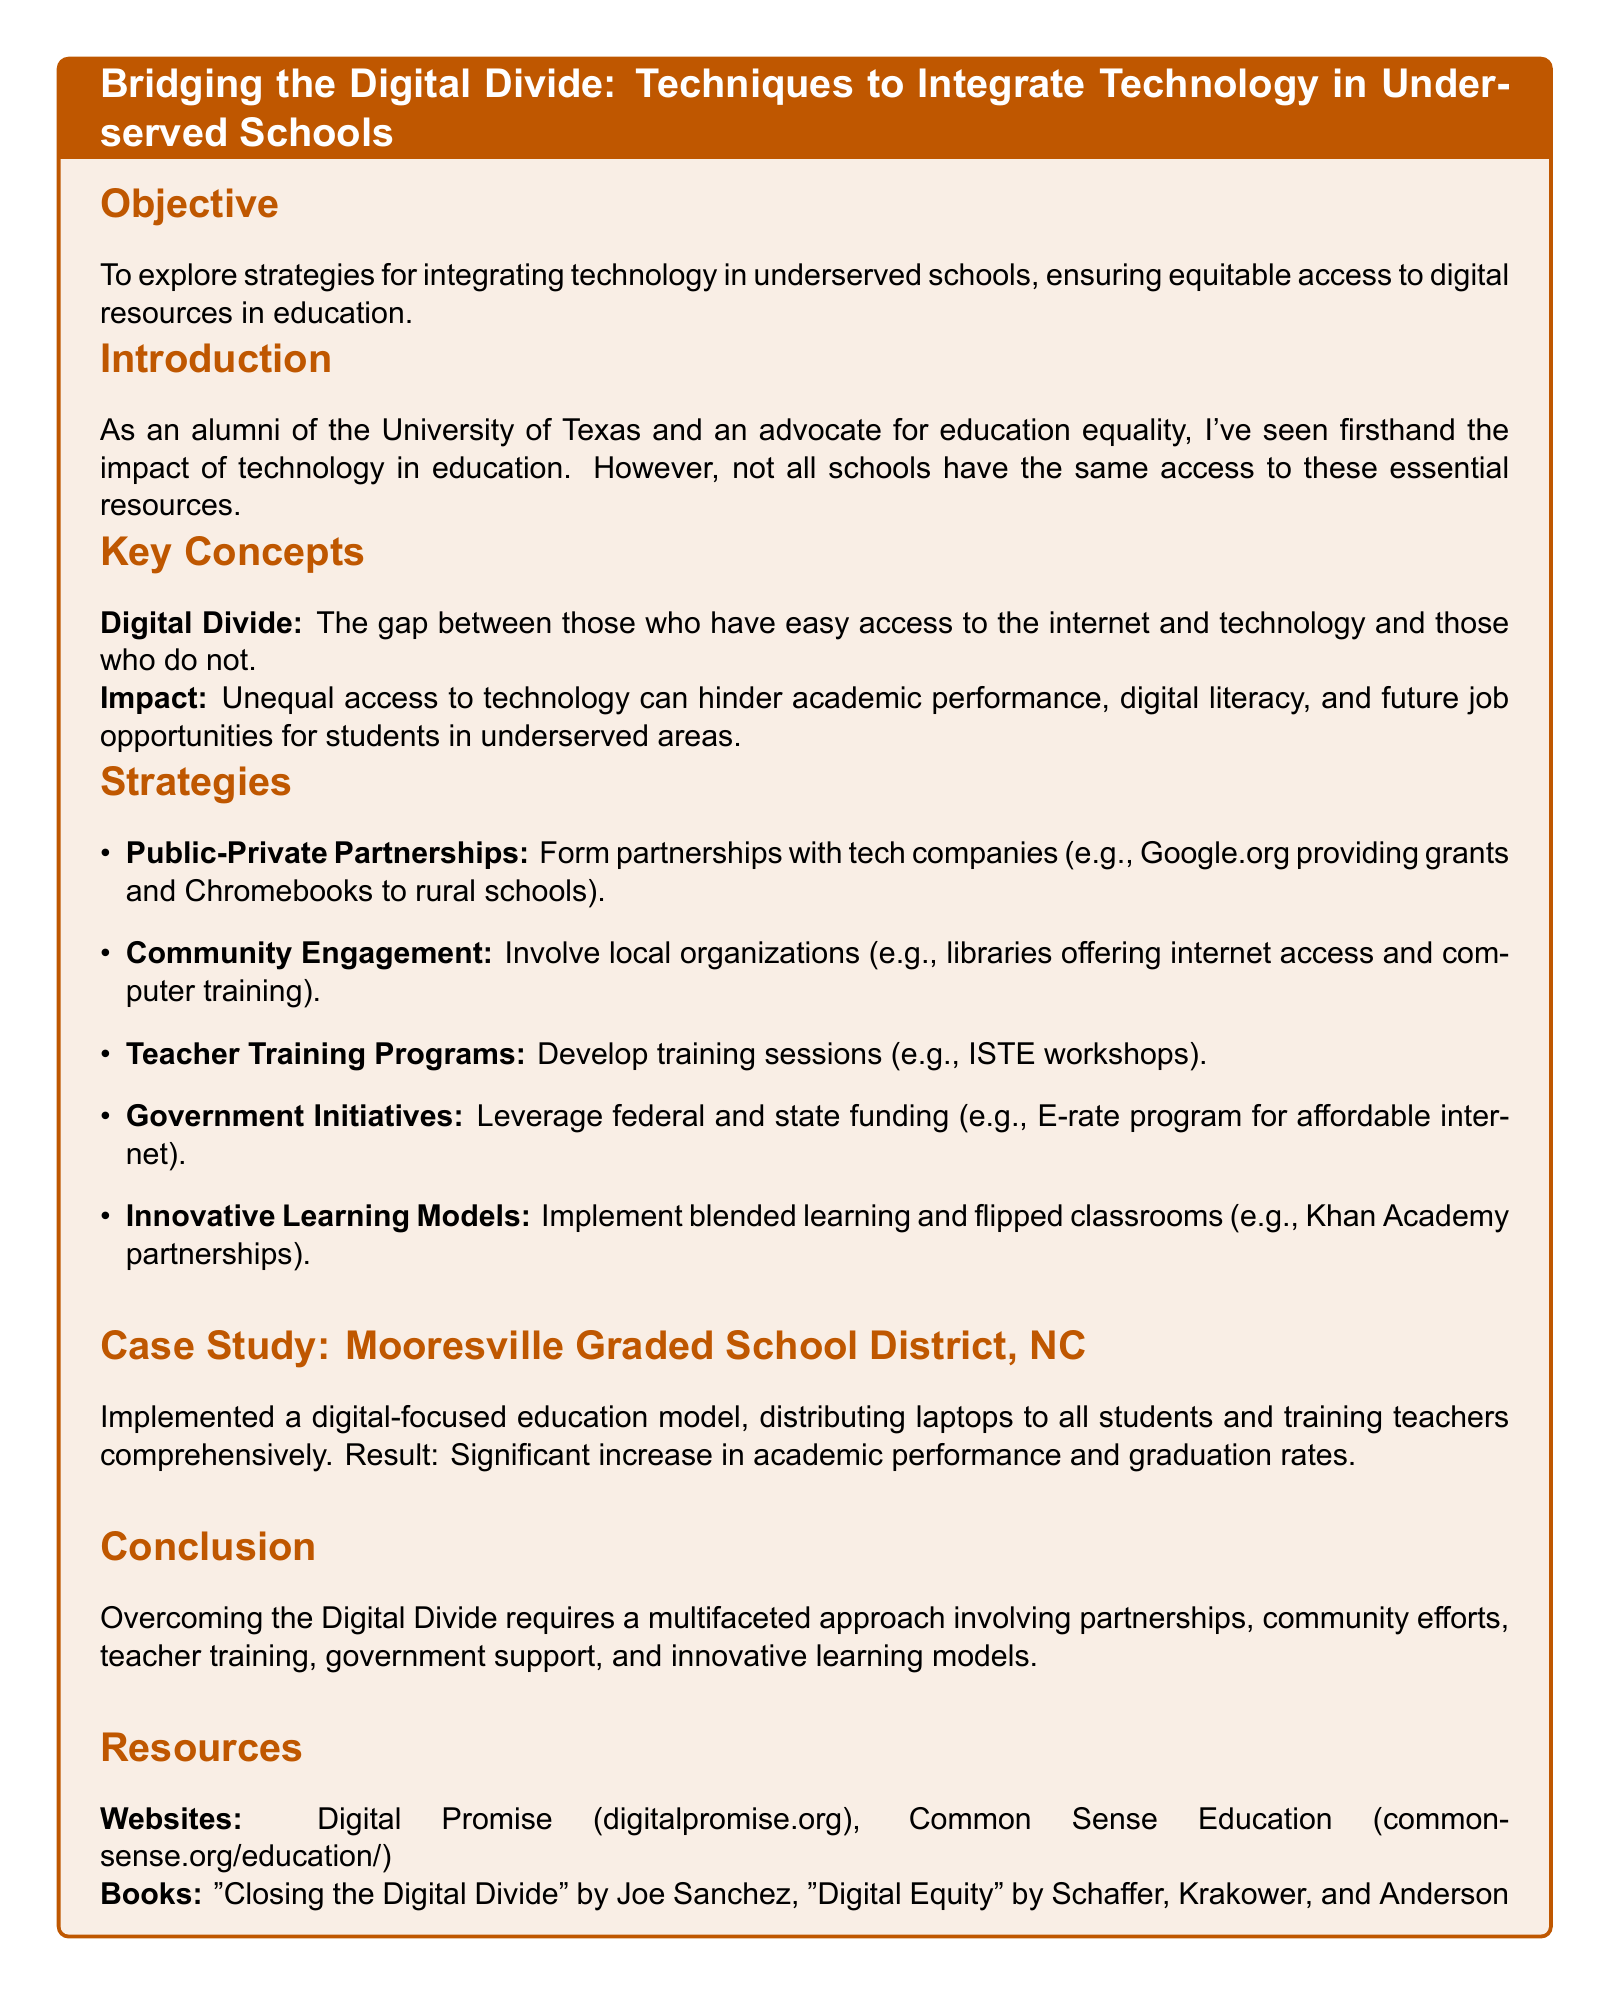What is the objective of the lesson plan? The lesson plan aims to explore strategies for integrating technology in underserved schools, ensuring equitable access to digital resources in education.
Answer: Strategies for integrating technology What is the digital divide? The document defines the digital divide as the gap between those who have easy access to the internet and technology and those who do not.
Answer: Gap between access to internet and technology Name one strategy mentioned for bridging the digital divide. The document lists several strategies and asks for just one, such as public-private partnerships.
Answer: Public-private partnerships What case study is presented in the document? The document includes a case study of the Mooresville Graded School District, NC.
Answer: Mooresville Graded School District, NC What was a result of the digital-focused education model in the case study? According to the document, the result of the model was a significant increase in academic performance and graduation rates.
Answer: Increased academic performance and graduation rates How many key concepts are outlined in the lesson plan? The lesson plan outlines two key concepts regarding digital divide and its impact.
Answer: Two Which organization is listed as a resource? The document provides digitalpromise.org as one of the websites for resources.
Answer: digitalpromise.org What training program is mentioned for teachers? The document mentions ISTE workshops as a training program for teachers.
Answer: ISTE workshops What is one innovative learning model discussed? The document discusses blended learning as one of the innovative learning models.
Answer: Blended learning 